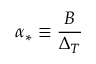<formula> <loc_0><loc_0><loc_500><loc_500>\alpha _ { \ast } \equiv \frac { B } { \Delta _ { T } }</formula> 